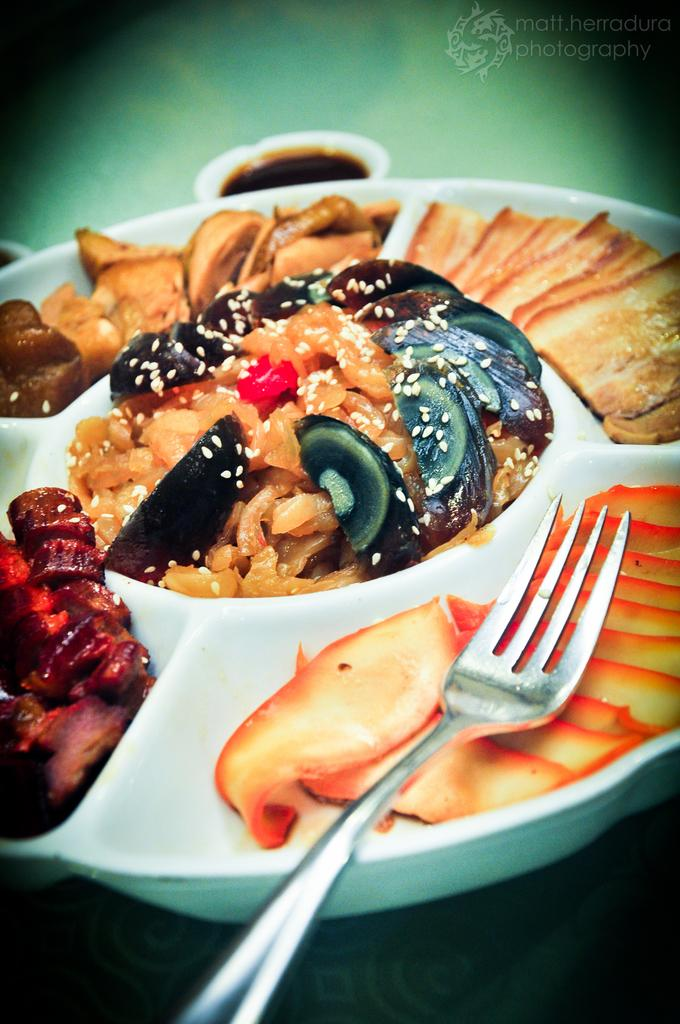What is on the plate that is visible in the image? There is a plate with food in the image. What utensil can be seen in the image? There is a fork in the image. What else is present in the image besides the plate and fork? There are objects in the image. How would you describe the background of the image? The background of the image is blurry. What can be found in the top right side of the image? There is a logo and text in the top right side of the image. What sound can be heard coming from the plate in the image? There is no sound coming from the plate in the image; it is a still image. 